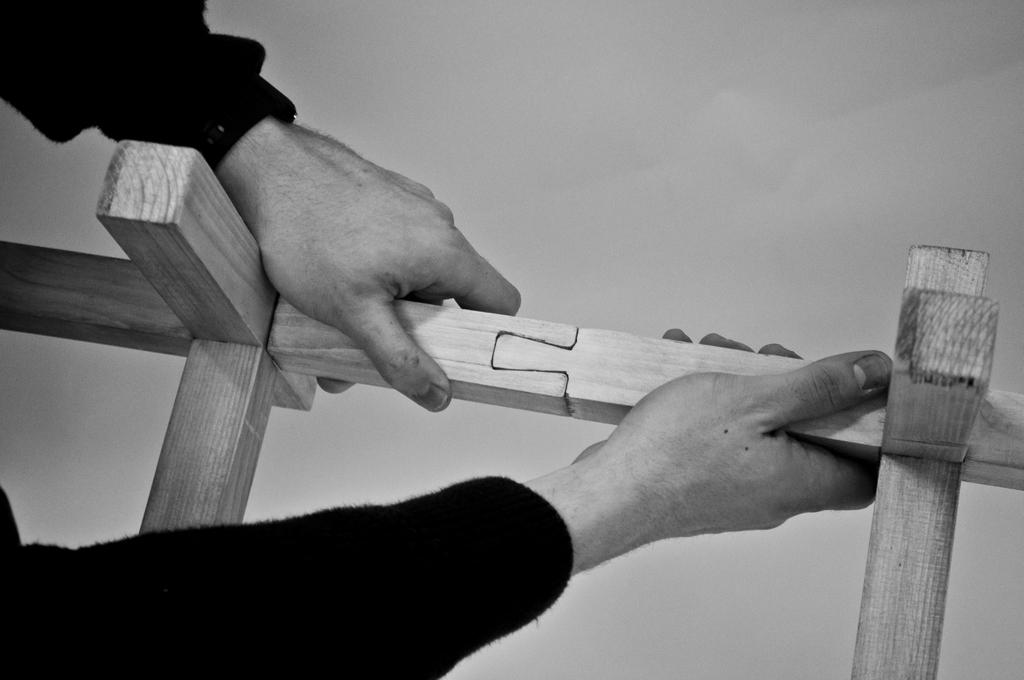What body parts are visible in the image? There are human hands in the image. What are the hands holding? The hands are holding wood. What type of insurance policy is being discussed by the laborer in the image? There is no laborer present in the image, nor is there any discussion about insurance policies. 